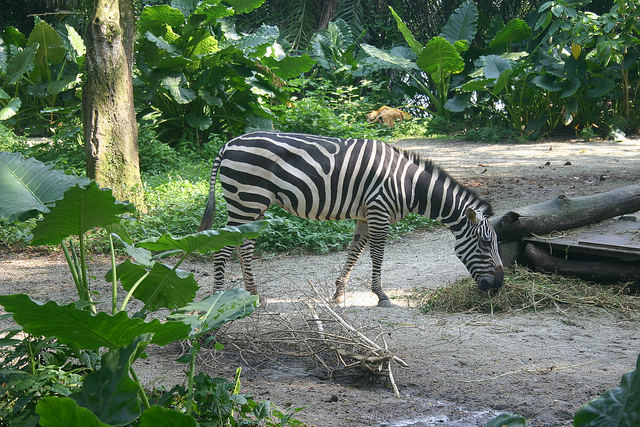<image>What kind of tree did that log come from? I don't know what kind of tree the log came from. It could be from a pine, oak, bamboo, banana, birch, or palm tree. What kind of tree did that log come from? I don't know the exact kind of tree that the log came from. It can be pine, oak, bamboo, banana, birch, or palm. 